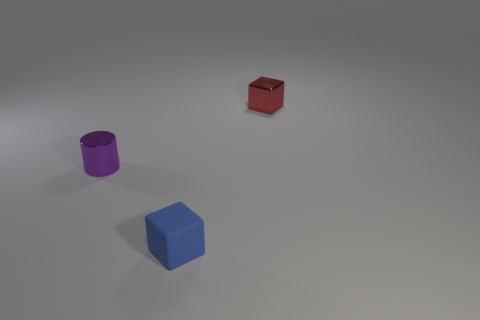Do the shiny cube and the tiny thing that is to the left of the small rubber object have the same color?
Provide a succinct answer. No. Is the number of large red balls greater than the number of small purple objects?
Offer a very short reply. No. The matte thing has what color?
Provide a short and direct response. Blue. Do the cube in front of the tiny shiny cube and the tiny metal block have the same color?
Keep it short and to the point. No. How many small metallic objects are the same color as the small cylinder?
Keep it short and to the point. 0. Is the shape of the metallic object that is behind the tiny cylinder the same as  the blue matte thing?
Provide a succinct answer. Yes. Are there fewer purple cylinders on the right side of the matte block than tiny metal cylinders on the left side of the tiny shiny cylinder?
Offer a terse response. No. What material is the object that is behind the tiny purple cylinder?
Your answer should be very brief. Metal. Is there a red metal object of the same size as the rubber thing?
Provide a short and direct response. Yes. There is a rubber thing; is its shape the same as the metallic object that is right of the cylinder?
Your answer should be very brief. Yes. 